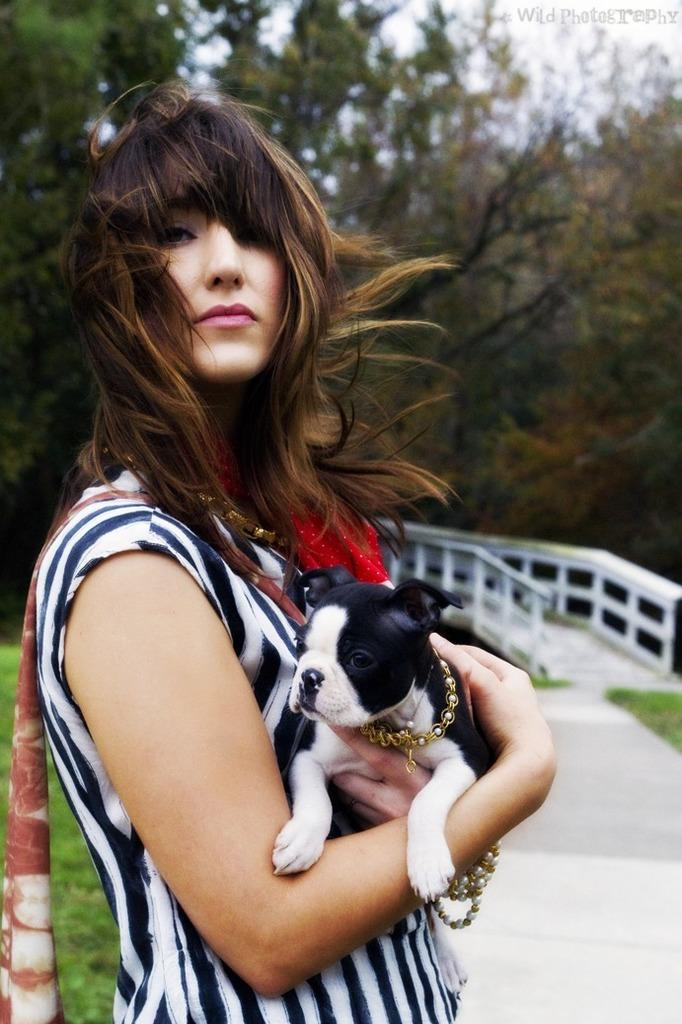What is the person in the image doing? The person is standing in the image and holding a dog. What can be seen in the background of the image? There are trees visible in the image. What type of tin is the person using to communicate with the committee in the image? There is no tin or committee present in the image; it features a person holding a dog and trees in the background. 